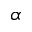Convert formula to latex. <formula><loc_0><loc_0><loc_500><loc_500>\alpha</formula> 